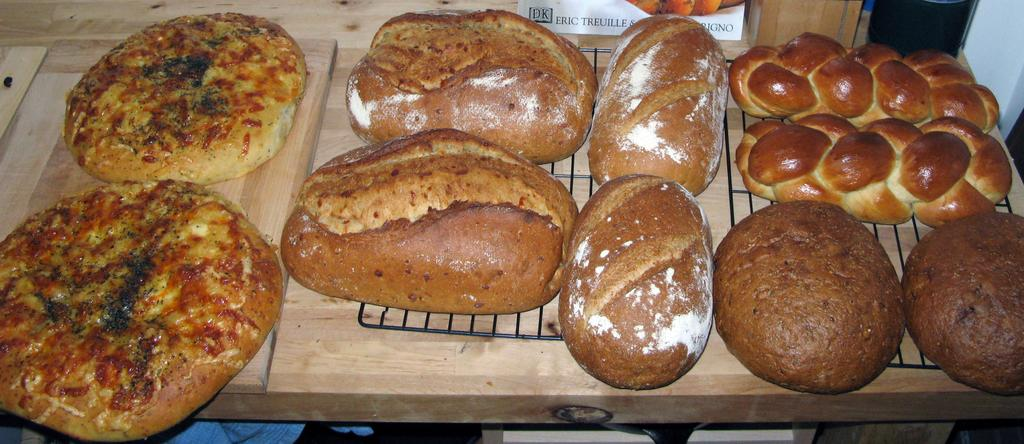What type of food items can be seen in the image? There are baked food items in the image. On what surface are the baked food items placed? The baked food items are kept on a wooden surface. Where is the mother in the image? There is no mother present in the image. What type of plants can be seen in the garden in the image? There is no garden present in the image. How many pails of water are visible in the image? There are no pails of water present in the image. 